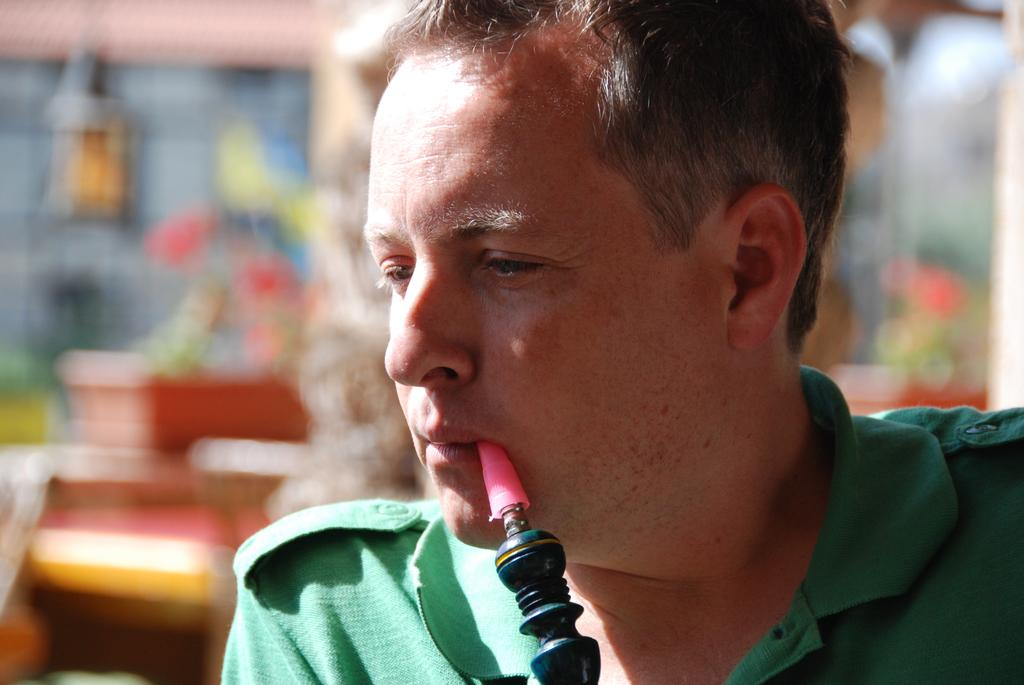What is the main subject of the image? There is a man in the image. What is the man doing in the image? There is an object near the man's mouth, which suggests he might be using it for something. Can you describe the background of the image? The background of the image is blurred. How does the man swim in the image? There is no indication of swimming in the image; the man is standing with an object near his mouth. What type of vessel is the man using in the image? There is no vessel present in the image. 